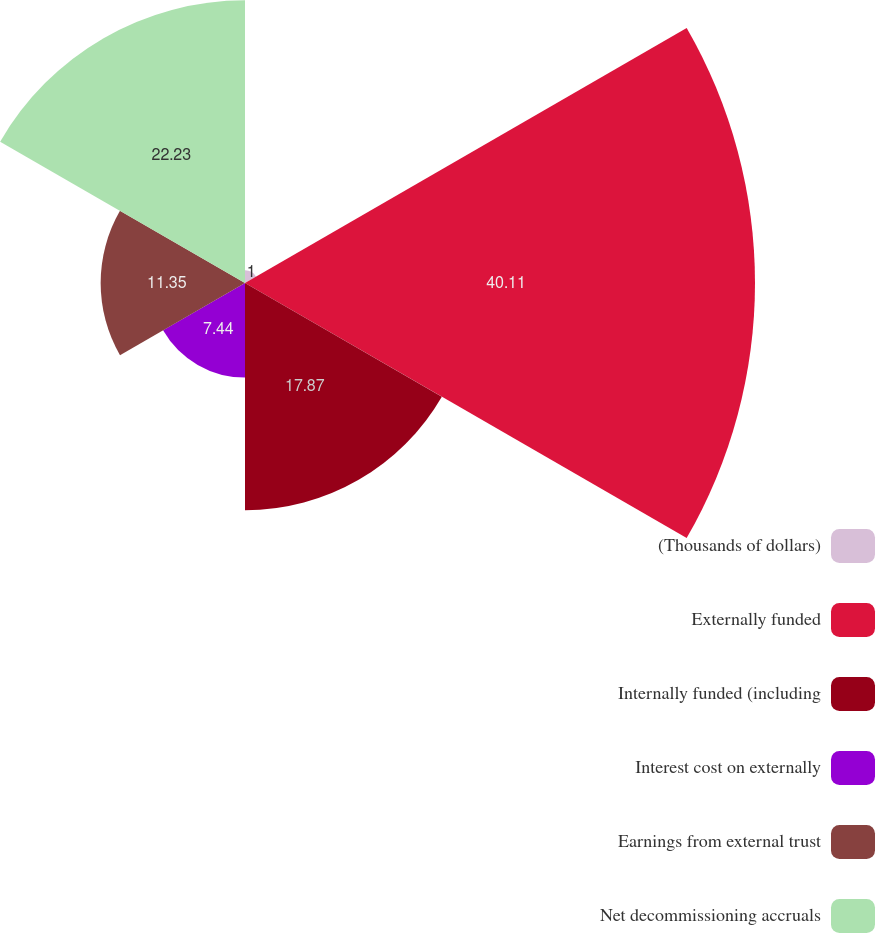<chart> <loc_0><loc_0><loc_500><loc_500><pie_chart><fcel>(Thousands of dollars)<fcel>Externally funded<fcel>Internally funded (including<fcel>Interest cost on externally<fcel>Earnings from external trust<fcel>Net decommissioning accruals<nl><fcel>1.0%<fcel>40.1%<fcel>17.87%<fcel>7.44%<fcel>11.35%<fcel>22.23%<nl></chart> 